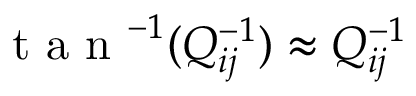<formula> <loc_0><loc_0><loc_500><loc_500>t a n ^ { - 1 } ( Q _ { i j } ^ { - 1 } ) \approx Q _ { i j } ^ { - 1 }</formula> 